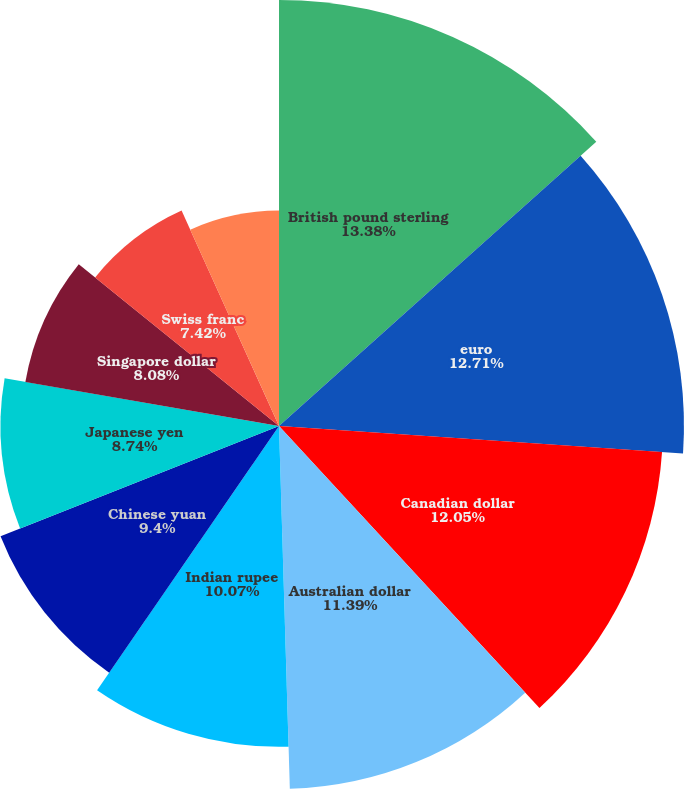<chart> <loc_0><loc_0><loc_500><loc_500><pie_chart><fcel>British pound sterling<fcel>euro<fcel>Canadian dollar<fcel>Australian dollar<fcel>Indian rupee<fcel>Chinese yuan<fcel>Japanese yen<fcel>Singapore dollar<fcel>Swiss franc<fcel>Brazilian real<nl><fcel>13.37%<fcel>12.71%<fcel>12.05%<fcel>11.39%<fcel>10.07%<fcel>9.4%<fcel>8.74%<fcel>8.08%<fcel>7.42%<fcel>6.76%<nl></chart> 